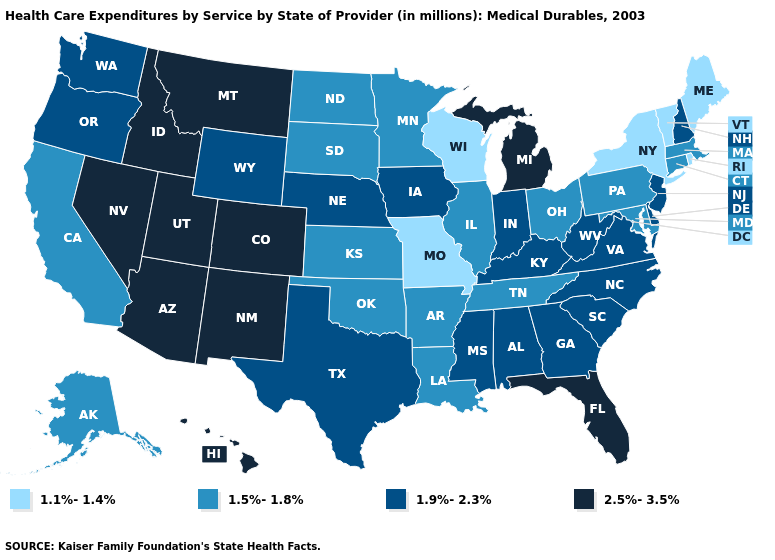Name the states that have a value in the range 1.5%-1.8%?
Give a very brief answer. Alaska, Arkansas, California, Connecticut, Illinois, Kansas, Louisiana, Maryland, Massachusetts, Minnesota, North Dakota, Ohio, Oklahoma, Pennsylvania, South Dakota, Tennessee. Among the states that border Oregon , does Washington have the highest value?
Short answer required. No. What is the value of West Virginia?
Concise answer only. 1.9%-2.3%. Which states have the lowest value in the West?
Quick response, please. Alaska, California. Among the states that border Maryland , does Delaware have the highest value?
Answer briefly. Yes. What is the lowest value in the USA?
Answer briefly. 1.1%-1.4%. Does Virginia have a higher value than Illinois?
Write a very short answer. Yes. Does Louisiana have the highest value in the South?
Keep it brief. No. Which states have the highest value in the USA?
Be succinct. Arizona, Colorado, Florida, Hawaii, Idaho, Michigan, Montana, Nevada, New Mexico, Utah. Does Arkansas have a lower value than Connecticut?
Concise answer only. No. Does Michigan have the same value as Maine?
Answer briefly. No. Name the states that have a value in the range 1.1%-1.4%?
Concise answer only. Maine, Missouri, New York, Rhode Island, Vermont, Wisconsin. Which states have the lowest value in the Northeast?
Answer briefly. Maine, New York, Rhode Island, Vermont. Name the states that have a value in the range 1.1%-1.4%?
Keep it brief. Maine, Missouri, New York, Rhode Island, Vermont, Wisconsin. 